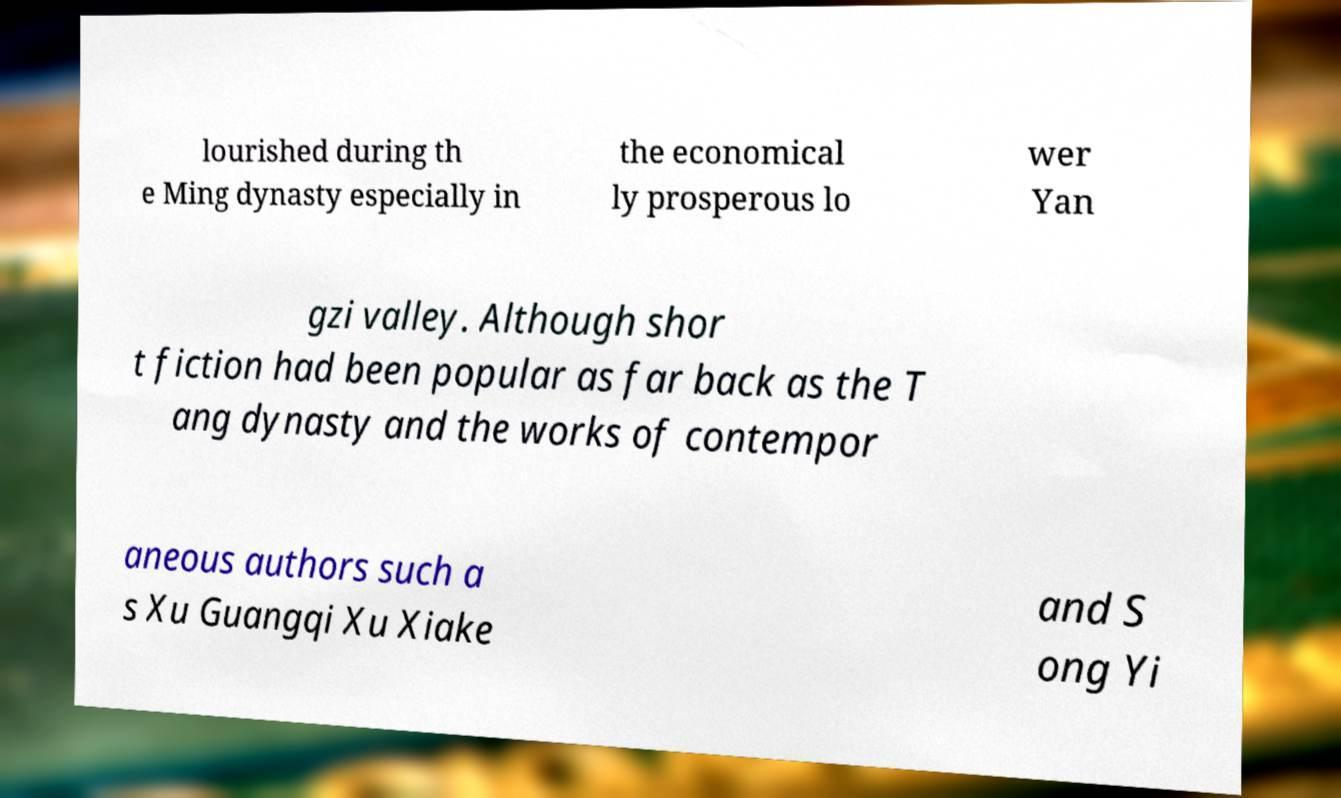There's text embedded in this image that I need extracted. Can you transcribe it verbatim? lourished during th e Ming dynasty especially in the economical ly prosperous lo wer Yan gzi valley. Although shor t fiction had been popular as far back as the T ang dynasty and the works of contempor aneous authors such a s Xu Guangqi Xu Xiake and S ong Yi 